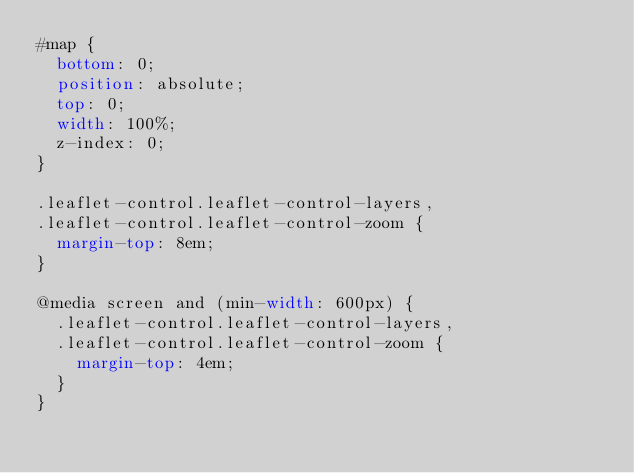Convert code to text. <code><loc_0><loc_0><loc_500><loc_500><_CSS_>#map {
	bottom: 0;
	position: absolute;
	top: 0;
	width: 100%;
	z-index: 0;
}

.leaflet-control.leaflet-control-layers,
.leaflet-control.leaflet-control-zoom {
	margin-top: 8em;
}

@media screen and (min-width: 600px) {
	.leaflet-control.leaflet-control-layers,
	.leaflet-control.leaflet-control-zoom {
		margin-top: 4em;
	}
}
</code> 